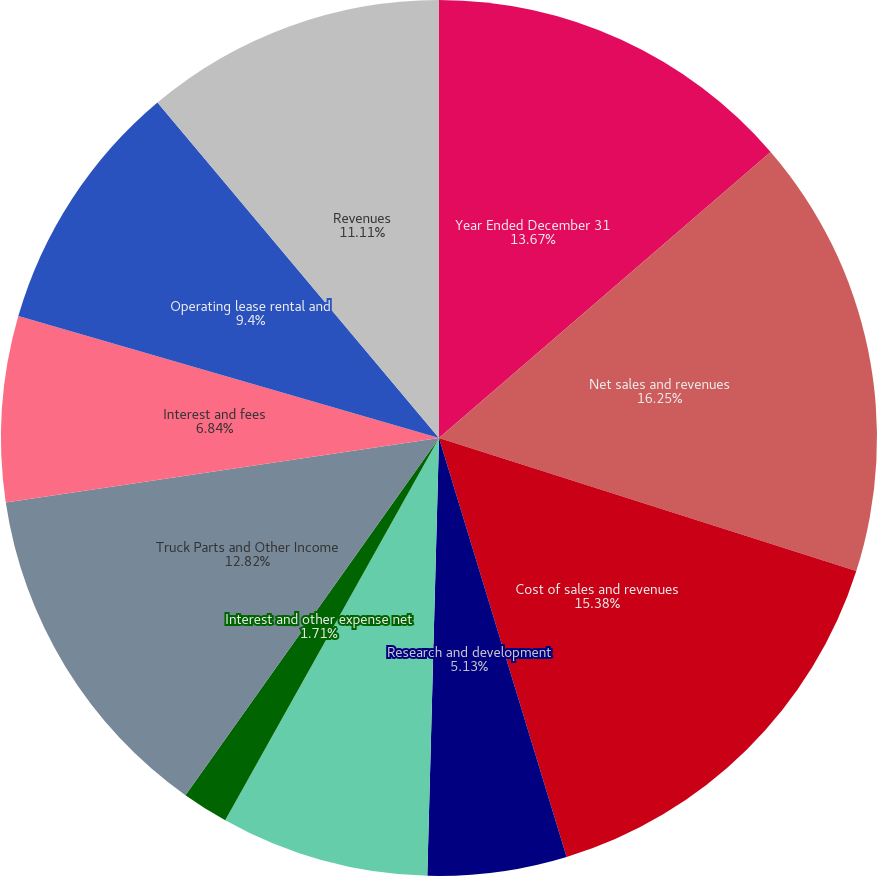Convert chart. <chart><loc_0><loc_0><loc_500><loc_500><pie_chart><fcel>Year Ended December 31<fcel>Net sales and revenues<fcel>Cost of sales and revenues<fcel>Research and development<fcel>Selling general and<fcel>Interest and other expense net<fcel>Truck Parts and Other Income<fcel>Interest and fees<fcel>Operating lease rental and<fcel>Revenues<nl><fcel>13.67%<fcel>16.24%<fcel>15.38%<fcel>5.13%<fcel>7.69%<fcel>1.71%<fcel>12.82%<fcel>6.84%<fcel>9.4%<fcel>11.11%<nl></chart> 